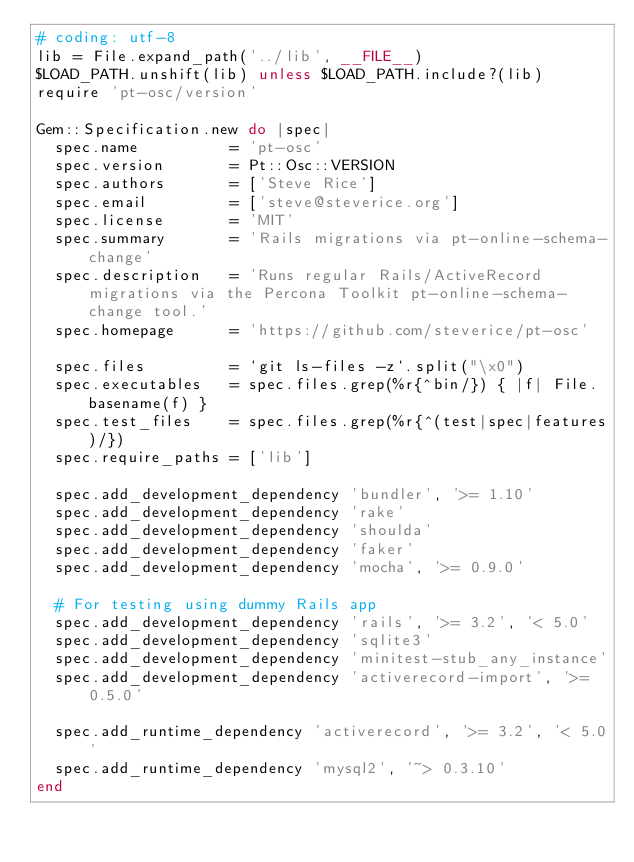<code> <loc_0><loc_0><loc_500><loc_500><_Ruby_># coding: utf-8
lib = File.expand_path('../lib', __FILE__)
$LOAD_PATH.unshift(lib) unless $LOAD_PATH.include?(lib)
require 'pt-osc/version'

Gem::Specification.new do |spec|
  spec.name          = 'pt-osc'
  spec.version       = Pt::Osc::VERSION
  spec.authors       = ['Steve Rice']
  spec.email         = ['steve@steverice.org']
  spec.license       = 'MIT'
  spec.summary       = 'Rails migrations via pt-online-schema-change'
  spec.description   = 'Runs regular Rails/ActiveRecord migrations via the Percona Toolkit pt-online-schema-change tool.'
  spec.homepage      = 'https://github.com/steverice/pt-osc'

  spec.files         = `git ls-files -z`.split("\x0")
  spec.executables   = spec.files.grep(%r{^bin/}) { |f| File.basename(f) }
  spec.test_files    = spec.files.grep(%r{^(test|spec|features)/})
  spec.require_paths = ['lib']

  spec.add_development_dependency 'bundler', '>= 1.10'
  spec.add_development_dependency 'rake'
  spec.add_development_dependency 'shoulda'
  spec.add_development_dependency 'faker'
  spec.add_development_dependency 'mocha', '>= 0.9.0'

  # For testing using dummy Rails app
  spec.add_development_dependency 'rails', '>= 3.2', '< 5.0'
  spec.add_development_dependency 'sqlite3'
  spec.add_development_dependency 'minitest-stub_any_instance'
  spec.add_development_dependency 'activerecord-import', '>= 0.5.0'

  spec.add_runtime_dependency 'activerecord', '>= 3.2', '< 5.0'
  spec.add_runtime_dependency 'mysql2', '~> 0.3.10'
end
</code> 